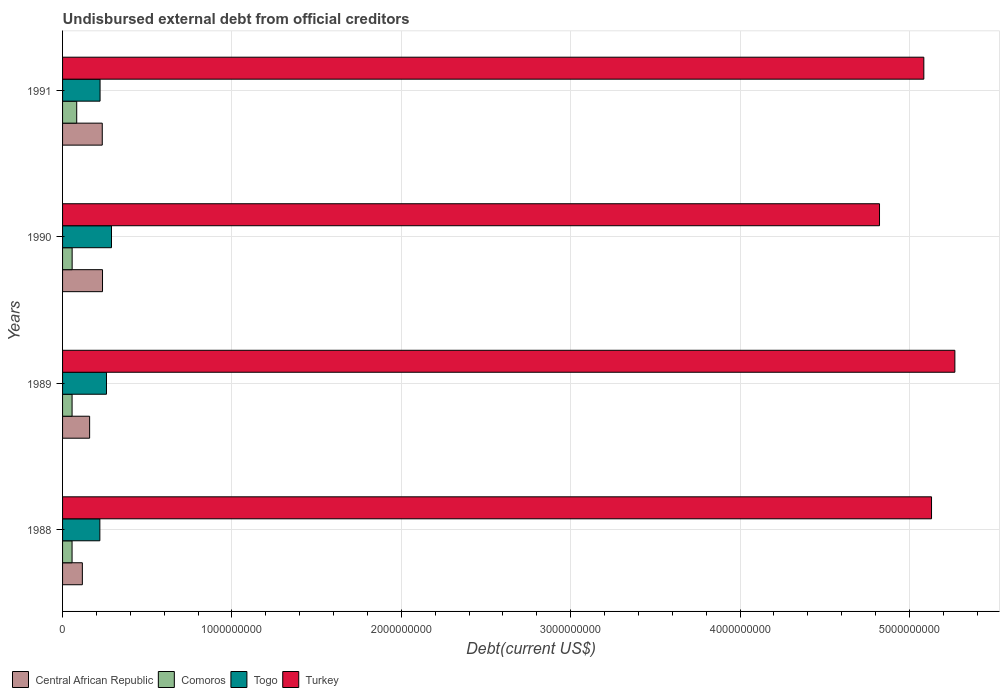How many different coloured bars are there?
Provide a succinct answer. 4. What is the total debt in Central African Republic in 1988?
Make the answer very short. 1.17e+08. Across all years, what is the maximum total debt in Central African Republic?
Your response must be concise. 2.36e+08. Across all years, what is the minimum total debt in Central African Republic?
Provide a succinct answer. 1.17e+08. In which year was the total debt in Togo minimum?
Your answer should be very brief. 1988. What is the total total debt in Comoros in the graph?
Give a very brief answer. 2.52e+08. What is the difference between the total debt in Central African Republic in 1988 and that in 1991?
Your answer should be very brief. -1.17e+08. What is the difference between the total debt in Central African Republic in 1990 and the total debt in Togo in 1988?
Provide a succinct answer. 1.57e+07. What is the average total debt in Togo per year?
Ensure brevity in your answer.  2.47e+08. In the year 1990, what is the difference between the total debt in Comoros and total debt in Togo?
Provide a short and direct response. -2.32e+08. In how many years, is the total debt in Togo greater than 200000000 US$?
Provide a succinct answer. 4. What is the ratio of the total debt in Central African Republic in 1988 to that in 1991?
Keep it short and to the point. 0.5. Is the total debt in Comoros in 1990 less than that in 1991?
Your answer should be very brief. Yes. Is the difference between the total debt in Comoros in 1989 and 1991 greater than the difference between the total debt in Togo in 1989 and 1991?
Make the answer very short. No. What is the difference between the highest and the second highest total debt in Comoros?
Your answer should be very brief. 2.70e+07. What is the difference between the highest and the lowest total debt in Turkey?
Make the answer very short. 4.45e+08. Is the sum of the total debt in Turkey in 1989 and 1990 greater than the maximum total debt in Comoros across all years?
Give a very brief answer. Yes. What does the 4th bar from the top in 1989 represents?
Your response must be concise. Central African Republic. What does the 3rd bar from the bottom in 1988 represents?
Keep it short and to the point. Togo. Is it the case that in every year, the sum of the total debt in Central African Republic and total debt in Comoros is greater than the total debt in Turkey?
Your answer should be compact. No. How many bars are there?
Offer a very short reply. 16. Are all the bars in the graph horizontal?
Ensure brevity in your answer.  Yes. How many years are there in the graph?
Keep it short and to the point. 4. What is the difference between two consecutive major ticks on the X-axis?
Offer a very short reply. 1.00e+09. Are the values on the major ticks of X-axis written in scientific E-notation?
Your response must be concise. No. Where does the legend appear in the graph?
Offer a very short reply. Bottom left. What is the title of the graph?
Provide a succinct answer. Undisbursed external debt from official creditors. Does "Libya" appear as one of the legend labels in the graph?
Provide a succinct answer. No. What is the label or title of the X-axis?
Keep it short and to the point. Debt(current US$). What is the Debt(current US$) in Central African Republic in 1988?
Give a very brief answer. 1.17e+08. What is the Debt(current US$) in Comoros in 1988?
Provide a short and direct response. 5.61e+07. What is the Debt(current US$) in Togo in 1988?
Provide a short and direct response. 2.20e+08. What is the Debt(current US$) of Turkey in 1988?
Provide a short and direct response. 5.13e+09. What is the Debt(current US$) in Central African Republic in 1989?
Give a very brief answer. 1.60e+08. What is the Debt(current US$) of Comoros in 1989?
Provide a short and direct response. 5.61e+07. What is the Debt(current US$) in Togo in 1989?
Give a very brief answer. 2.59e+08. What is the Debt(current US$) of Turkey in 1989?
Offer a terse response. 5.27e+09. What is the Debt(current US$) of Central African Republic in 1990?
Your answer should be very brief. 2.36e+08. What is the Debt(current US$) of Comoros in 1990?
Your response must be concise. 5.65e+07. What is the Debt(current US$) of Togo in 1990?
Your answer should be very brief. 2.89e+08. What is the Debt(current US$) in Turkey in 1990?
Your answer should be very brief. 4.82e+09. What is the Debt(current US$) in Central African Republic in 1991?
Provide a short and direct response. 2.34e+08. What is the Debt(current US$) in Comoros in 1991?
Provide a succinct answer. 8.36e+07. What is the Debt(current US$) of Togo in 1991?
Your response must be concise. 2.21e+08. What is the Debt(current US$) of Turkey in 1991?
Provide a succinct answer. 5.08e+09. Across all years, what is the maximum Debt(current US$) in Central African Republic?
Offer a terse response. 2.36e+08. Across all years, what is the maximum Debt(current US$) in Comoros?
Provide a succinct answer. 8.36e+07. Across all years, what is the maximum Debt(current US$) in Togo?
Your answer should be very brief. 2.89e+08. Across all years, what is the maximum Debt(current US$) of Turkey?
Your answer should be very brief. 5.27e+09. Across all years, what is the minimum Debt(current US$) in Central African Republic?
Give a very brief answer. 1.17e+08. Across all years, what is the minimum Debt(current US$) in Comoros?
Offer a terse response. 5.61e+07. Across all years, what is the minimum Debt(current US$) of Togo?
Offer a very short reply. 2.20e+08. Across all years, what is the minimum Debt(current US$) in Turkey?
Ensure brevity in your answer.  4.82e+09. What is the total Debt(current US$) in Central African Republic in the graph?
Make the answer very short. 7.47e+08. What is the total Debt(current US$) of Comoros in the graph?
Offer a very short reply. 2.52e+08. What is the total Debt(current US$) of Togo in the graph?
Keep it short and to the point. 9.90e+08. What is the total Debt(current US$) of Turkey in the graph?
Offer a very short reply. 2.03e+1. What is the difference between the Debt(current US$) in Central African Republic in 1988 and that in 1989?
Your answer should be compact. -4.29e+07. What is the difference between the Debt(current US$) in Comoros in 1988 and that in 1989?
Provide a succinct answer. -2.90e+04. What is the difference between the Debt(current US$) of Togo in 1988 and that in 1989?
Your answer should be very brief. -3.91e+07. What is the difference between the Debt(current US$) in Turkey in 1988 and that in 1989?
Give a very brief answer. -1.38e+08. What is the difference between the Debt(current US$) in Central African Republic in 1988 and that in 1990?
Ensure brevity in your answer.  -1.19e+08. What is the difference between the Debt(current US$) in Comoros in 1988 and that in 1990?
Offer a very short reply. -4.29e+05. What is the difference between the Debt(current US$) in Togo in 1988 and that in 1990?
Offer a terse response. -6.87e+07. What is the difference between the Debt(current US$) in Turkey in 1988 and that in 1990?
Give a very brief answer. 3.07e+08. What is the difference between the Debt(current US$) in Central African Republic in 1988 and that in 1991?
Ensure brevity in your answer.  -1.17e+08. What is the difference between the Debt(current US$) of Comoros in 1988 and that in 1991?
Your response must be concise. -2.75e+07. What is the difference between the Debt(current US$) of Togo in 1988 and that in 1991?
Your answer should be very brief. -1.28e+06. What is the difference between the Debt(current US$) in Turkey in 1988 and that in 1991?
Your answer should be very brief. 4.55e+07. What is the difference between the Debt(current US$) in Central African Republic in 1989 and that in 1990?
Keep it short and to the point. -7.61e+07. What is the difference between the Debt(current US$) in Comoros in 1989 and that in 1990?
Your answer should be compact. -4.00e+05. What is the difference between the Debt(current US$) of Togo in 1989 and that in 1990?
Make the answer very short. -2.96e+07. What is the difference between the Debt(current US$) in Turkey in 1989 and that in 1990?
Keep it short and to the point. 4.45e+08. What is the difference between the Debt(current US$) in Central African Republic in 1989 and that in 1991?
Offer a very short reply. -7.46e+07. What is the difference between the Debt(current US$) in Comoros in 1989 and that in 1991?
Your answer should be compact. -2.74e+07. What is the difference between the Debt(current US$) of Togo in 1989 and that in 1991?
Offer a very short reply. 3.78e+07. What is the difference between the Debt(current US$) of Turkey in 1989 and that in 1991?
Give a very brief answer. 1.83e+08. What is the difference between the Debt(current US$) in Central African Republic in 1990 and that in 1991?
Your response must be concise. 1.48e+06. What is the difference between the Debt(current US$) of Comoros in 1990 and that in 1991?
Keep it short and to the point. -2.70e+07. What is the difference between the Debt(current US$) in Togo in 1990 and that in 1991?
Offer a very short reply. 6.75e+07. What is the difference between the Debt(current US$) of Turkey in 1990 and that in 1991?
Offer a very short reply. -2.62e+08. What is the difference between the Debt(current US$) of Central African Republic in 1988 and the Debt(current US$) of Comoros in 1989?
Provide a succinct answer. 6.07e+07. What is the difference between the Debt(current US$) in Central African Republic in 1988 and the Debt(current US$) in Togo in 1989?
Offer a very short reply. -1.42e+08. What is the difference between the Debt(current US$) of Central African Republic in 1988 and the Debt(current US$) of Turkey in 1989?
Provide a short and direct response. -5.15e+09. What is the difference between the Debt(current US$) of Comoros in 1988 and the Debt(current US$) of Togo in 1989?
Offer a terse response. -2.03e+08. What is the difference between the Debt(current US$) in Comoros in 1988 and the Debt(current US$) in Turkey in 1989?
Ensure brevity in your answer.  -5.21e+09. What is the difference between the Debt(current US$) of Togo in 1988 and the Debt(current US$) of Turkey in 1989?
Provide a short and direct response. -5.05e+09. What is the difference between the Debt(current US$) in Central African Republic in 1988 and the Debt(current US$) in Comoros in 1990?
Offer a very short reply. 6.03e+07. What is the difference between the Debt(current US$) in Central African Republic in 1988 and the Debt(current US$) in Togo in 1990?
Offer a very short reply. -1.72e+08. What is the difference between the Debt(current US$) of Central African Republic in 1988 and the Debt(current US$) of Turkey in 1990?
Ensure brevity in your answer.  -4.71e+09. What is the difference between the Debt(current US$) in Comoros in 1988 and the Debt(current US$) in Togo in 1990?
Offer a terse response. -2.33e+08. What is the difference between the Debt(current US$) of Comoros in 1988 and the Debt(current US$) of Turkey in 1990?
Your response must be concise. -4.77e+09. What is the difference between the Debt(current US$) of Togo in 1988 and the Debt(current US$) of Turkey in 1990?
Give a very brief answer. -4.60e+09. What is the difference between the Debt(current US$) of Central African Republic in 1988 and the Debt(current US$) of Comoros in 1991?
Your answer should be very brief. 3.33e+07. What is the difference between the Debt(current US$) of Central African Republic in 1988 and the Debt(current US$) of Togo in 1991?
Keep it short and to the point. -1.05e+08. What is the difference between the Debt(current US$) of Central African Republic in 1988 and the Debt(current US$) of Turkey in 1991?
Offer a terse response. -4.97e+09. What is the difference between the Debt(current US$) in Comoros in 1988 and the Debt(current US$) in Togo in 1991?
Your answer should be compact. -1.65e+08. What is the difference between the Debt(current US$) in Comoros in 1988 and the Debt(current US$) in Turkey in 1991?
Provide a short and direct response. -5.03e+09. What is the difference between the Debt(current US$) in Togo in 1988 and the Debt(current US$) in Turkey in 1991?
Make the answer very short. -4.86e+09. What is the difference between the Debt(current US$) of Central African Republic in 1989 and the Debt(current US$) of Comoros in 1990?
Your answer should be compact. 1.03e+08. What is the difference between the Debt(current US$) in Central African Republic in 1989 and the Debt(current US$) in Togo in 1990?
Provide a short and direct response. -1.29e+08. What is the difference between the Debt(current US$) of Central African Republic in 1989 and the Debt(current US$) of Turkey in 1990?
Keep it short and to the point. -4.66e+09. What is the difference between the Debt(current US$) in Comoros in 1989 and the Debt(current US$) in Togo in 1990?
Make the answer very short. -2.33e+08. What is the difference between the Debt(current US$) in Comoros in 1989 and the Debt(current US$) in Turkey in 1990?
Your answer should be compact. -4.77e+09. What is the difference between the Debt(current US$) of Togo in 1989 and the Debt(current US$) of Turkey in 1990?
Make the answer very short. -4.56e+09. What is the difference between the Debt(current US$) of Central African Republic in 1989 and the Debt(current US$) of Comoros in 1991?
Your response must be concise. 7.62e+07. What is the difference between the Debt(current US$) of Central African Republic in 1989 and the Debt(current US$) of Togo in 1991?
Give a very brief answer. -6.16e+07. What is the difference between the Debt(current US$) in Central African Republic in 1989 and the Debt(current US$) in Turkey in 1991?
Your answer should be compact. -4.92e+09. What is the difference between the Debt(current US$) in Comoros in 1989 and the Debt(current US$) in Togo in 1991?
Offer a terse response. -1.65e+08. What is the difference between the Debt(current US$) in Comoros in 1989 and the Debt(current US$) in Turkey in 1991?
Offer a terse response. -5.03e+09. What is the difference between the Debt(current US$) in Togo in 1989 and the Debt(current US$) in Turkey in 1991?
Keep it short and to the point. -4.83e+09. What is the difference between the Debt(current US$) in Central African Republic in 1990 and the Debt(current US$) in Comoros in 1991?
Provide a succinct answer. 1.52e+08. What is the difference between the Debt(current US$) of Central African Republic in 1990 and the Debt(current US$) of Togo in 1991?
Provide a short and direct response. 1.44e+07. What is the difference between the Debt(current US$) in Central African Republic in 1990 and the Debt(current US$) in Turkey in 1991?
Provide a succinct answer. -4.85e+09. What is the difference between the Debt(current US$) of Comoros in 1990 and the Debt(current US$) of Togo in 1991?
Ensure brevity in your answer.  -1.65e+08. What is the difference between the Debt(current US$) in Comoros in 1990 and the Debt(current US$) in Turkey in 1991?
Make the answer very short. -5.03e+09. What is the difference between the Debt(current US$) in Togo in 1990 and the Debt(current US$) in Turkey in 1991?
Provide a short and direct response. -4.80e+09. What is the average Debt(current US$) of Central African Republic per year?
Keep it short and to the point. 1.87e+08. What is the average Debt(current US$) in Comoros per year?
Give a very brief answer. 6.31e+07. What is the average Debt(current US$) of Togo per year?
Give a very brief answer. 2.47e+08. What is the average Debt(current US$) in Turkey per year?
Offer a very short reply. 5.08e+09. In the year 1988, what is the difference between the Debt(current US$) in Central African Republic and Debt(current US$) in Comoros?
Provide a succinct answer. 6.08e+07. In the year 1988, what is the difference between the Debt(current US$) in Central African Republic and Debt(current US$) in Togo?
Your answer should be compact. -1.03e+08. In the year 1988, what is the difference between the Debt(current US$) in Central African Republic and Debt(current US$) in Turkey?
Offer a very short reply. -5.01e+09. In the year 1988, what is the difference between the Debt(current US$) in Comoros and Debt(current US$) in Togo?
Make the answer very short. -1.64e+08. In the year 1988, what is the difference between the Debt(current US$) of Comoros and Debt(current US$) of Turkey?
Your answer should be very brief. -5.07e+09. In the year 1988, what is the difference between the Debt(current US$) in Togo and Debt(current US$) in Turkey?
Keep it short and to the point. -4.91e+09. In the year 1989, what is the difference between the Debt(current US$) in Central African Republic and Debt(current US$) in Comoros?
Give a very brief answer. 1.04e+08. In the year 1989, what is the difference between the Debt(current US$) in Central African Republic and Debt(current US$) in Togo?
Keep it short and to the point. -9.95e+07. In the year 1989, what is the difference between the Debt(current US$) in Central African Republic and Debt(current US$) in Turkey?
Make the answer very short. -5.11e+09. In the year 1989, what is the difference between the Debt(current US$) in Comoros and Debt(current US$) in Togo?
Make the answer very short. -2.03e+08. In the year 1989, what is the difference between the Debt(current US$) of Comoros and Debt(current US$) of Turkey?
Keep it short and to the point. -5.21e+09. In the year 1989, what is the difference between the Debt(current US$) in Togo and Debt(current US$) in Turkey?
Your answer should be very brief. -5.01e+09. In the year 1990, what is the difference between the Debt(current US$) of Central African Republic and Debt(current US$) of Comoros?
Your answer should be compact. 1.79e+08. In the year 1990, what is the difference between the Debt(current US$) in Central African Republic and Debt(current US$) in Togo?
Provide a short and direct response. -5.30e+07. In the year 1990, what is the difference between the Debt(current US$) in Central African Republic and Debt(current US$) in Turkey?
Your answer should be compact. -4.59e+09. In the year 1990, what is the difference between the Debt(current US$) in Comoros and Debt(current US$) in Togo?
Your answer should be very brief. -2.32e+08. In the year 1990, what is the difference between the Debt(current US$) of Comoros and Debt(current US$) of Turkey?
Offer a very short reply. -4.77e+09. In the year 1990, what is the difference between the Debt(current US$) of Togo and Debt(current US$) of Turkey?
Offer a terse response. -4.53e+09. In the year 1991, what is the difference between the Debt(current US$) of Central African Republic and Debt(current US$) of Comoros?
Your response must be concise. 1.51e+08. In the year 1991, what is the difference between the Debt(current US$) of Central African Republic and Debt(current US$) of Togo?
Provide a short and direct response. 1.29e+07. In the year 1991, what is the difference between the Debt(current US$) of Central African Republic and Debt(current US$) of Turkey?
Your response must be concise. -4.85e+09. In the year 1991, what is the difference between the Debt(current US$) in Comoros and Debt(current US$) in Togo?
Provide a succinct answer. -1.38e+08. In the year 1991, what is the difference between the Debt(current US$) in Comoros and Debt(current US$) in Turkey?
Your answer should be compact. -5.00e+09. In the year 1991, what is the difference between the Debt(current US$) of Togo and Debt(current US$) of Turkey?
Make the answer very short. -4.86e+09. What is the ratio of the Debt(current US$) of Central African Republic in 1988 to that in 1989?
Offer a terse response. 0.73. What is the ratio of the Debt(current US$) of Togo in 1988 to that in 1989?
Make the answer very short. 0.85. What is the ratio of the Debt(current US$) of Turkey in 1988 to that in 1989?
Your answer should be compact. 0.97. What is the ratio of the Debt(current US$) in Central African Republic in 1988 to that in 1990?
Offer a very short reply. 0.5. What is the ratio of the Debt(current US$) in Comoros in 1988 to that in 1990?
Make the answer very short. 0.99. What is the ratio of the Debt(current US$) of Togo in 1988 to that in 1990?
Provide a short and direct response. 0.76. What is the ratio of the Debt(current US$) in Turkey in 1988 to that in 1990?
Keep it short and to the point. 1.06. What is the ratio of the Debt(current US$) in Central African Republic in 1988 to that in 1991?
Offer a terse response. 0.5. What is the ratio of the Debt(current US$) in Comoros in 1988 to that in 1991?
Provide a short and direct response. 0.67. What is the ratio of the Debt(current US$) of Turkey in 1988 to that in 1991?
Provide a succinct answer. 1.01. What is the ratio of the Debt(current US$) of Central African Republic in 1989 to that in 1990?
Make the answer very short. 0.68. What is the ratio of the Debt(current US$) in Togo in 1989 to that in 1990?
Offer a very short reply. 0.9. What is the ratio of the Debt(current US$) of Turkey in 1989 to that in 1990?
Your answer should be compact. 1.09. What is the ratio of the Debt(current US$) in Central African Republic in 1989 to that in 1991?
Offer a very short reply. 0.68. What is the ratio of the Debt(current US$) in Comoros in 1989 to that in 1991?
Offer a very short reply. 0.67. What is the ratio of the Debt(current US$) of Togo in 1989 to that in 1991?
Ensure brevity in your answer.  1.17. What is the ratio of the Debt(current US$) in Turkey in 1989 to that in 1991?
Offer a very short reply. 1.04. What is the ratio of the Debt(current US$) of Comoros in 1990 to that in 1991?
Give a very brief answer. 0.68. What is the ratio of the Debt(current US$) of Togo in 1990 to that in 1991?
Your response must be concise. 1.3. What is the ratio of the Debt(current US$) in Turkey in 1990 to that in 1991?
Ensure brevity in your answer.  0.95. What is the difference between the highest and the second highest Debt(current US$) in Central African Republic?
Provide a short and direct response. 1.48e+06. What is the difference between the highest and the second highest Debt(current US$) in Comoros?
Offer a terse response. 2.70e+07. What is the difference between the highest and the second highest Debt(current US$) of Togo?
Your answer should be very brief. 2.96e+07. What is the difference between the highest and the second highest Debt(current US$) in Turkey?
Make the answer very short. 1.38e+08. What is the difference between the highest and the lowest Debt(current US$) of Central African Republic?
Make the answer very short. 1.19e+08. What is the difference between the highest and the lowest Debt(current US$) of Comoros?
Your answer should be very brief. 2.75e+07. What is the difference between the highest and the lowest Debt(current US$) in Togo?
Offer a terse response. 6.87e+07. What is the difference between the highest and the lowest Debt(current US$) in Turkey?
Provide a succinct answer. 4.45e+08. 